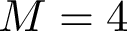<formula> <loc_0><loc_0><loc_500><loc_500>M = 4</formula> 